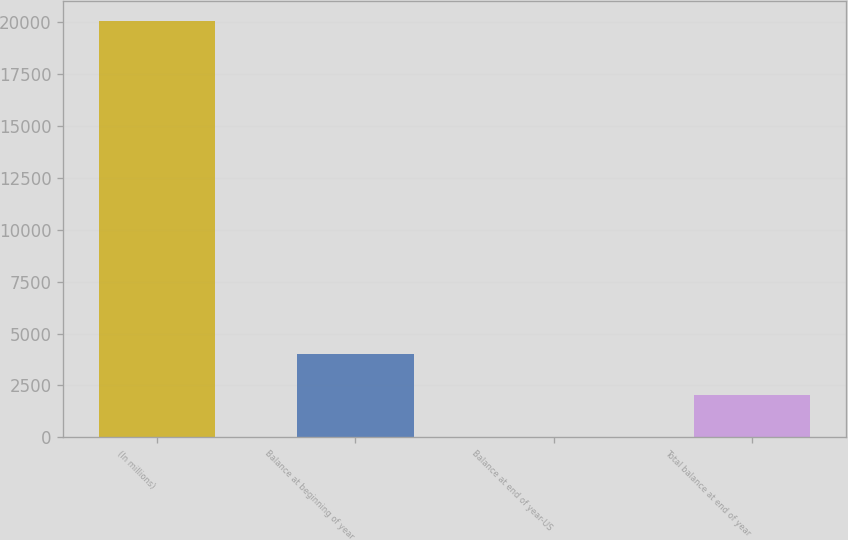Convert chart to OTSL. <chart><loc_0><loc_0><loc_500><loc_500><bar_chart><fcel>(In millions)<fcel>Balance at beginning of year<fcel>Balance at end of year-US<fcel>Total balance at end of year<nl><fcel>20041<fcel>4019.4<fcel>14<fcel>2016.7<nl></chart> 